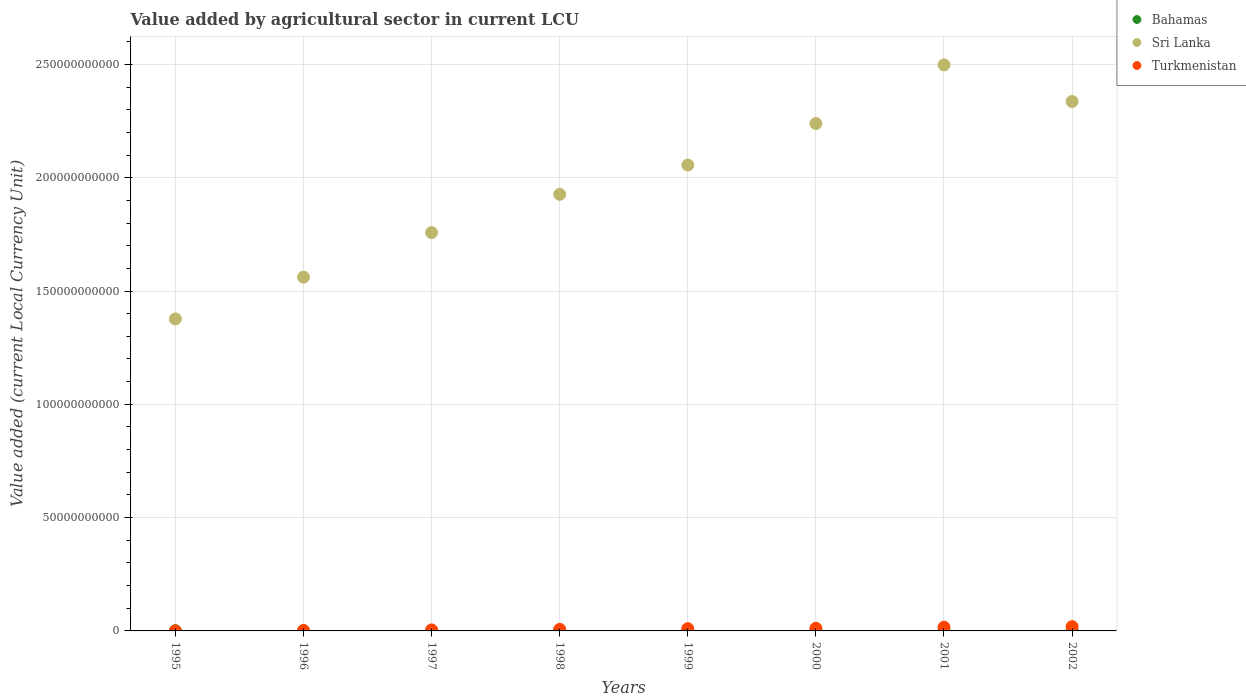What is the value added by agricultural sector in Turkmenistan in 2002?
Provide a short and direct response. 1.89e+09. Across all years, what is the maximum value added by agricultural sector in Bahamas?
Your response must be concise. 2.02e+08. Across all years, what is the minimum value added by agricultural sector in Bahamas?
Make the answer very short. 9.55e+07. In which year was the value added by agricultural sector in Sri Lanka minimum?
Provide a short and direct response. 1995. What is the total value added by agricultural sector in Turkmenistan in the graph?
Your response must be concise. 7.10e+09. What is the difference between the value added by agricultural sector in Sri Lanka in 1995 and that in 1998?
Your answer should be very brief. -5.50e+1. What is the difference between the value added by agricultural sector in Turkmenistan in 2002 and the value added by agricultural sector in Sri Lanka in 1995?
Offer a very short reply. -1.36e+11. What is the average value added by agricultural sector in Turkmenistan per year?
Provide a short and direct response. 8.88e+08. In the year 1995, what is the difference between the value added by agricultural sector in Bahamas and value added by agricultural sector in Turkmenistan?
Provide a short and direct response. 7.60e+07. What is the ratio of the value added by agricultural sector in Turkmenistan in 1997 to that in 1998?
Make the answer very short. 0.64. Is the value added by agricultural sector in Bahamas in 1995 less than that in 2002?
Provide a short and direct response. Yes. What is the difference between the highest and the second highest value added by agricultural sector in Sri Lanka?
Make the answer very short. 1.62e+1. What is the difference between the highest and the lowest value added by agricultural sector in Turkmenistan?
Offer a terse response. 1.87e+09. In how many years, is the value added by agricultural sector in Sri Lanka greater than the average value added by agricultural sector in Sri Lanka taken over all years?
Offer a very short reply. 4. Is the sum of the value added by agricultural sector in Turkmenistan in 1998 and 2002 greater than the maximum value added by agricultural sector in Sri Lanka across all years?
Ensure brevity in your answer.  No. Is it the case that in every year, the sum of the value added by agricultural sector in Bahamas and value added by agricultural sector in Turkmenistan  is greater than the value added by agricultural sector in Sri Lanka?
Make the answer very short. No. Is the value added by agricultural sector in Sri Lanka strictly greater than the value added by agricultural sector in Turkmenistan over the years?
Offer a very short reply. Yes. How many dotlines are there?
Your answer should be compact. 3. How many years are there in the graph?
Provide a short and direct response. 8. What is the difference between two consecutive major ticks on the Y-axis?
Provide a short and direct response. 5.00e+1. Are the values on the major ticks of Y-axis written in scientific E-notation?
Keep it short and to the point. No. Where does the legend appear in the graph?
Give a very brief answer. Top right. What is the title of the graph?
Your response must be concise. Value added by agricultural sector in current LCU. Does "Kuwait" appear as one of the legend labels in the graph?
Your answer should be very brief. No. What is the label or title of the X-axis?
Your response must be concise. Years. What is the label or title of the Y-axis?
Offer a very short reply. Value added (current Local Currency Unit). What is the Value added (current Local Currency Unit) in Bahamas in 1995?
Your response must be concise. 9.72e+07. What is the Value added (current Local Currency Unit) of Sri Lanka in 1995?
Provide a succinct answer. 1.38e+11. What is the Value added (current Local Currency Unit) in Turkmenistan in 1995?
Provide a succinct answer. 2.11e+07. What is the Value added (current Local Currency Unit) in Bahamas in 1996?
Your response must be concise. 9.55e+07. What is the Value added (current Local Currency Unit) of Sri Lanka in 1996?
Keep it short and to the point. 1.56e+11. What is the Value added (current Local Currency Unit) of Turkmenistan in 1996?
Keep it short and to the point. 1.96e+08. What is the Value added (current Local Currency Unit) in Bahamas in 1997?
Offer a very short reply. 1.54e+08. What is the Value added (current Local Currency Unit) in Sri Lanka in 1997?
Ensure brevity in your answer.  1.76e+11. What is the Value added (current Local Currency Unit) in Turkmenistan in 1997?
Your response must be concise. 4.50e+08. What is the Value added (current Local Currency Unit) of Bahamas in 1998?
Keep it short and to the point. 1.47e+08. What is the Value added (current Local Currency Unit) of Sri Lanka in 1998?
Your response must be concise. 1.93e+11. What is the Value added (current Local Currency Unit) in Turkmenistan in 1998?
Offer a very short reply. 7.04e+08. What is the Value added (current Local Currency Unit) in Bahamas in 1999?
Your response must be concise. 1.48e+08. What is the Value added (current Local Currency Unit) in Sri Lanka in 1999?
Ensure brevity in your answer.  2.06e+11. What is the Value added (current Local Currency Unit) of Turkmenistan in 1999?
Provide a succinct answer. 9.96e+08. What is the Value added (current Local Currency Unit) of Bahamas in 2000?
Your response must be concise. 1.66e+08. What is the Value added (current Local Currency Unit) of Sri Lanka in 2000?
Provide a short and direct response. 2.24e+11. What is the Value added (current Local Currency Unit) of Turkmenistan in 2000?
Offer a very short reply. 1.18e+09. What is the Value added (current Local Currency Unit) of Bahamas in 2001?
Ensure brevity in your answer.  1.57e+08. What is the Value added (current Local Currency Unit) in Sri Lanka in 2001?
Ensure brevity in your answer.  2.50e+11. What is the Value added (current Local Currency Unit) of Turkmenistan in 2001?
Provide a short and direct response. 1.67e+09. What is the Value added (current Local Currency Unit) in Bahamas in 2002?
Your answer should be compact. 2.02e+08. What is the Value added (current Local Currency Unit) of Sri Lanka in 2002?
Your answer should be compact. 2.34e+11. What is the Value added (current Local Currency Unit) in Turkmenistan in 2002?
Your response must be concise. 1.89e+09. Across all years, what is the maximum Value added (current Local Currency Unit) in Bahamas?
Offer a terse response. 2.02e+08. Across all years, what is the maximum Value added (current Local Currency Unit) of Sri Lanka?
Your answer should be very brief. 2.50e+11. Across all years, what is the maximum Value added (current Local Currency Unit) of Turkmenistan?
Provide a short and direct response. 1.89e+09. Across all years, what is the minimum Value added (current Local Currency Unit) of Bahamas?
Your answer should be compact. 9.55e+07. Across all years, what is the minimum Value added (current Local Currency Unit) in Sri Lanka?
Keep it short and to the point. 1.38e+11. Across all years, what is the minimum Value added (current Local Currency Unit) of Turkmenistan?
Your answer should be compact. 2.11e+07. What is the total Value added (current Local Currency Unit) in Bahamas in the graph?
Provide a short and direct response. 1.17e+09. What is the total Value added (current Local Currency Unit) in Sri Lanka in the graph?
Your response must be concise. 1.58e+12. What is the total Value added (current Local Currency Unit) in Turkmenistan in the graph?
Your answer should be compact. 7.10e+09. What is the difference between the Value added (current Local Currency Unit) of Bahamas in 1995 and that in 1996?
Offer a very short reply. 1.66e+06. What is the difference between the Value added (current Local Currency Unit) of Sri Lanka in 1995 and that in 1996?
Ensure brevity in your answer.  -1.84e+1. What is the difference between the Value added (current Local Currency Unit) in Turkmenistan in 1995 and that in 1996?
Your response must be concise. -1.75e+08. What is the difference between the Value added (current Local Currency Unit) of Bahamas in 1995 and that in 1997?
Give a very brief answer. -5.66e+07. What is the difference between the Value added (current Local Currency Unit) in Sri Lanka in 1995 and that in 1997?
Offer a very short reply. -3.81e+1. What is the difference between the Value added (current Local Currency Unit) of Turkmenistan in 1995 and that in 1997?
Offer a terse response. -4.28e+08. What is the difference between the Value added (current Local Currency Unit) in Bahamas in 1995 and that in 1998?
Offer a very short reply. -4.99e+07. What is the difference between the Value added (current Local Currency Unit) of Sri Lanka in 1995 and that in 1998?
Give a very brief answer. -5.50e+1. What is the difference between the Value added (current Local Currency Unit) of Turkmenistan in 1995 and that in 1998?
Your answer should be compact. -6.83e+08. What is the difference between the Value added (current Local Currency Unit) of Bahamas in 1995 and that in 1999?
Ensure brevity in your answer.  -5.08e+07. What is the difference between the Value added (current Local Currency Unit) in Sri Lanka in 1995 and that in 1999?
Keep it short and to the point. -6.79e+1. What is the difference between the Value added (current Local Currency Unit) in Turkmenistan in 1995 and that in 1999?
Offer a very short reply. -9.75e+08. What is the difference between the Value added (current Local Currency Unit) of Bahamas in 1995 and that in 2000?
Keep it short and to the point. -6.85e+07. What is the difference between the Value added (current Local Currency Unit) of Sri Lanka in 1995 and that in 2000?
Offer a terse response. -8.62e+1. What is the difference between the Value added (current Local Currency Unit) in Turkmenistan in 1995 and that in 2000?
Ensure brevity in your answer.  -1.16e+09. What is the difference between the Value added (current Local Currency Unit) in Bahamas in 1995 and that in 2001?
Provide a succinct answer. -5.99e+07. What is the difference between the Value added (current Local Currency Unit) of Sri Lanka in 1995 and that in 2001?
Give a very brief answer. -1.12e+11. What is the difference between the Value added (current Local Currency Unit) of Turkmenistan in 1995 and that in 2001?
Provide a succinct answer. -1.64e+09. What is the difference between the Value added (current Local Currency Unit) of Bahamas in 1995 and that in 2002?
Make the answer very short. -1.05e+08. What is the difference between the Value added (current Local Currency Unit) in Sri Lanka in 1995 and that in 2002?
Your answer should be very brief. -9.59e+1. What is the difference between the Value added (current Local Currency Unit) in Turkmenistan in 1995 and that in 2002?
Your response must be concise. -1.87e+09. What is the difference between the Value added (current Local Currency Unit) in Bahamas in 1996 and that in 1997?
Provide a short and direct response. -5.82e+07. What is the difference between the Value added (current Local Currency Unit) in Sri Lanka in 1996 and that in 1997?
Provide a succinct answer. -1.97e+1. What is the difference between the Value added (current Local Currency Unit) of Turkmenistan in 1996 and that in 1997?
Provide a short and direct response. -2.54e+08. What is the difference between the Value added (current Local Currency Unit) in Bahamas in 1996 and that in 1998?
Keep it short and to the point. -5.16e+07. What is the difference between the Value added (current Local Currency Unit) in Sri Lanka in 1996 and that in 1998?
Offer a terse response. -3.66e+1. What is the difference between the Value added (current Local Currency Unit) of Turkmenistan in 1996 and that in 1998?
Offer a terse response. -5.08e+08. What is the difference between the Value added (current Local Currency Unit) of Bahamas in 1996 and that in 1999?
Your answer should be compact. -5.24e+07. What is the difference between the Value added (current Local Currency Unit) of Sri Lanka in 1996 and that in 1999?
Your answer should be very brief. -4.95e+1. What is the difference between the Value added (current Local Currency Unit) of Turkmenistan in 1996 and that in 1999?
Ensure brevity in your answer.  -8.01e+08. What is the difference between the Value added (current Local Currency Unit) in Bahamas in 1996 and that in 2000?
Give a very brief answer. -7.01e+07. What is the difference between the Value added (current Local Currency Unit) of Sri Lanka in 1996 and that in 2000?
Provide a succinct answer. -6.78e+1. What is the difference between the Value added (current Local Currency Unit) of Turkmenistan in 1996 and that in 2000?
Ensure brevity in your answer.  -9.81e+08. What is the difference between the Value added (current Local Currency Unit) in Bahamas in 1996 and that in 2001?
Your answer should be very brief. -6.16e+07. What is the difference between the Value added (current Local Currency Unit) of Sri Lanka in 1996 and that in 2001?
Give a very brief answer. -9.37e+1. What is the difference between the Value added (current Local Currency Unit) of Turkmenistan in 1996 and that in 2001?
Make the answer very short. -1.47e+09. What is the difference between the Value added (current Local Currency Unit) of Bahamas in 1996 and that in 2002?
Make the answer very short. -1.06e+08. What is the difference between the Value added (current Local Currency Unit) in Sri Lanka in 1996 and that in 2002?
Your answer should be compact. -7.75e+1. What is the difference between the Value added (current Local Currency Unit) of Turkmenistan in 1996 and that in 2002?
Your answer should be compact. -1.70e+09. What is the difference between the Value added (current Local Currency Unit) of Bahamas in 1997 and that in 1998?
Your answer should be compact. 6.64e+06. What is the difference between the Value added (current Local Currency Unit) in Sri Lanka in 1997 and that in 1998?
Provide a succinct answer. -1.69e+1. What is the difference between the Value added (current Local Currency Unit) in Turkmenistan in 1997 and that in 1998?
Offer a terse response. -2.55e+08. What is the difference between the Value added (current Local Currency Unit) in Bahamas in 1997 and that in 1999?
Your response must be concise. 5.82e+06. What is the difference between the Value added (current Local Currency Unit) in Sri Lanka in 1997 and that in 1999?
Give a very brief answer. -2.98e+1. What is the difference between the Value added (current Local Currency Unit) in Turkmenistan in 1997 and that in 1999?
Offer a very short reply. -5.47e+08. What is the difference between the Value added (current Local Currency Unit) in Bahamas in 1997 and that in 2000?
Offer a very short reply. -1.19e+07. What is the difference between the Value added (current Local Currency Unit) in Sri Lanka in 1997 and that in 2000?
Give a very brief answer. -4.82e+1. What is the difference between the Value added (current Local Currency Unit) of Turkmenistan in 1997 and that in 2000?
Provide a short and direct response. -7.28e+08. What is the difference between the Value added (current Local Currency Unit) in Bahamas in 1997 and that in 2001?
Provide a succinct answer. -3.32e+06. What is the difference between the Value added (current Local Currency Unit) of Sri Lanka in 1997 and that in 2001?
Your response must be concise. -7.40e+1. What is the difference between the Value added (current Local Currency Unit) of Turkmenistan in 1997 and that in 2001?
Your response must be concise. -1.22e+09. What is the difference between the Value added (current Local Currency Unit) in Bahamas in 1997 and that in 2002?
Give a very brief answer. -4.81e+07. What is the difference between the Value added (current Local Currency Unit) in Sri Lanka in 1997 and that in 2002?
Offer a terse response. -5.78e+1. What is the difference between the Value added (current Local Currency Unit) in Turkmenistan in 1997 and that in 2002?
Give a very brief answer. -1.44e+09. What is the difference between the Value added (current Local Currency Unit) of Bahamas in 1998 and that in 1999?
Give a very brief answer. -8.26e+05. What is the difference between the Value added (current Local Currency Unit) in Sri Lanka in 1998 and that in 1999?
Provide a succinct answer. -1.29e+1. What is the difference between the Value added (current Local Currency Unit) in Turkmenistan in 1998 and that in 1999?
Ensure brevity in your answer.  -2.92e+08. What is the difference between the Value added (current Local Currency Unit) of Bahamas in 1998 and that in 2000?
Make the answer very short. -1.85e+07. What is the difference between the Value added (current Local Currency Unit) of Sri Lanka in 1998 and that in 2000?
Your answer should be compact. -3.13e+1. What is the difference between the Value added (current Local Currency Unit) in Turkmenistan in 1998 and that in 2000?
Offer a terse response. -4.73e+08. What is the difference between the Value added (current Local Currency Unit) of Bahamas in 1998 and that in 2001?
Give a very brief answer. -9.96e+06. What is the difference between the Value added (current Local Currency Unit) of Sri Lanka in 1998 and that in 2001?
Keep it short and to the point. -5.71e+1. What is the difference between the Value added (current Local Currency Unit) in Turkmenistan in 1998 and that in 2001?
Offer a terse response. -9.61e+08. What is the difference between the Value added (current Local Currency Unit) of Bahamas in 1998 and that in 2002?
Offer a very short reply. -5.47e+07. What is the difference between the Value added (current Local Currency Unit) of Sri Lanka in 1998 and that in 2002?
Provide a succinct answer. -4.10e+1. What is the difference between the Value added (current Local Currency Unit) of Turkmenistan in 1998 and that in 2002?
Provide a short and direct response. -1.19e+09. What is the difference between the Value added (current Local Currency Unit) of Bahamas in 1999 and that in 2000?
Provide a succinct answer. -1.77e+07. What is the difference between the Value added (current Local Currency Unit) of Sri Lanka in 1999 and that in 2000?
Make the answer very short. -1.83e+1. What is the difference between the Value added (current Local Currency Unit) in Turkmenistan in 1999 and that in 2000?
Provide a short and direct response. -1.81e+08. What is the difference between the Value added (current Local Currency Unit) of Bahamas in 1999 and that in 2001?
Give a very brief answer. -9.13e+06. What is the difference between the Value added (current Local Currency Unit) in Sri Lanka in 1999 and that in 2001?
Provide a succinct answer. -4.42e+1. What is the difference between the Value added (current Local Currency Unit) in Turkmenistan in 1999 and that in 2001?
Keep it short and to the point. -6.69e+08. What is the difference between the Value added (current Local Currency Unit) in Bahamas in 1999 and that in 2002?
Give a very brief answer. -5.39e+07. What is the difference between the Value added (current Local Currency Unit) of Sri Lanka in 1999 and that in 2002?
Keep it short and to the point. -2.80e+1. What is the difference between the Value added (current Local Currency Unit) in Turkmenistan in 1999 and that in 2002?
Ensure brevity in your answer.  -8.98e+08. What is the difference between the Value added (current Local Currency Unit) in Bahamas in 2000 and that in 2001?
Offer a very short reply. 8.59e+06. What is the difference between the Value added (current Local Currency Unit) of Sri Lanka in 2000 and that in 2001?
Offer a very short reply. -2.59e+1. What is the difference between the Value added (current Local Currency Unit) in Turkmenistan in 2000 and that in 2001?
Offer a very short reply. -4.88e+08. What is the difference between the Value added (current Local Currency Unit) in Bahamas in 2000 and that in 2002?
Make the answer very short. -3.62e+07. What is the difference between the Value added (current Local Currency Unit) in Sri Lanka in 2000 and that in 2002?
Make the answer very short. -9.69e+09. What is the difference between the Value added (current Local Currency Unit) of Turkmenistan in 2000 and that in 2002?
Keep it short and to the point. -7.17e+08. What is the difference between the Value added (current Local Currency Unit) of Bahamas in 2001 and that in 2002?
Your answer should be very brief. -4.48e+07. What is the difference between the Value added (current Local Currency Unit) in Sri Lanka in 2001 and that in 2002?
Your answer should be compact. 1.62e+1. What is the difference between the Value added (current Local Currency Unit) in Turkmenistan in 2001 and that in 2002?
Offer a terse response. -2.28e+08. What is the difference between the Value added (current Local Currency Unit) of Bahamas in 1995 and the Value added (current Local Currency Unit) of Sri Lanka in 1996?
Ensure brevity in your answer.  -1.56e+11. What is the difference between the Value added (current Local Currency Unit) in Bahamas in 1995 and the Value added (current Local Currency Unit) in Turkmenistan in 1996?
Give a very brief answer. -9.86e+07. What is the difference between the Value added (current Local Currency Unit) of Sri Lanka in 1995 and the Value added (current Local Currency Unit) of Turkmenistan in 1996?
Make the answer very short. 1.37e+11. What is the difference between the Value added (current Local Currency Unit) in Bahamas in 1995 and the Value added (current Local Currency Unit) in Sri Lanka in 1997?
Offer a terse response. -1.76e+11. What is the difference between the Value added (current Local Currency Unit) of Bahamas in 1995 and the Value added (current Local Currency Unit) of Turkmenistan in 1997?
Ensure brevity in your answer.  -3.52e+08. What is the difference between the Value added (current Local Currency Unit) in Sri Lanka in 1995 and the Value added (current Local Currency Unit) in Turkmenistan in 1997?
Offer a terse response. 1.37e+11. What is the difference between the Value added (current Local Currency Unit) of Bahamas in 1995 and the Value added (current Local Currency Unit) of Sri Lanka in 1998?
Your answer should be compact. -1.93e+11. What is the difference between the Value added (current Local Currency Unit) in Bahamas in 1995 and the Value added (current Local Currency Unit) in Turkmenistan in 1998?
Ensure brevity in your answer.  -6.07e+08. What is the difference between the Value added (current Local Currency Unit) in Sri Lanka in 1995 and the Value added (current Local Currency Unit) in Turkmenistan in 1998?
Provide a short and direct response. 1.37e+11. What is the difference between the Value added (current Local Currency Unit) of Bahamas in 1995 and the Value added (current Local Currency Unit) of Sri Lanka in 1999?
Make the answer very short. -2.06e+11. What is the difference between the Value added (current Local Currency Unit) in Bahamas in 1995 and the Value added (current Local Currency Unit) in Turkmenistan in 1999?
Make the answer very short. -8.99e+08. What is the difference between the Value added (current Local Currency Unit) in Sri Lanka in 1995 and the Value added (current Local Currency Unit) in Turkmenistan in 1999?
Give a very brief answer. 1.37e+11. What is the difference between the Value added (current Local Currency Unit) in Bahamas in 1995 and the Value added (current Local Currency Unit) in Sri Lanka in 2000?
Keep it short and to the point. -2.24e+11. What is the difference between the Value added (current Local Currency Unit) of Bahamas in 1995 and the Value added (current Local Currency Unit) of Turkmenistan in 2000?
Offer a terse response. -1.08e+09. What is the difference between the Value added (current Local Currency Unit) of Sri Lanka in 1995 and the Value added (current Local Currency Unit) of Turkmenistan in 2000?
Provide a succinct answer. 1.37e+11. What is the difference between the Value added (current Local Currency Unit) in Bahamas in 1995 and the Value added (current Local Currency Unit) in Sri Lanka in 2001?
Ensure brevity in your answer.  -2.50e+11. What is the difference between the Value added (current Local Currency Unit) of Bahamas in 1995 and the Value added (current Local Currency Unit) of Turkmenistan in 2001?
Your answer should be compact. -1.57e+09. What is the difference between the Value added (current Local Currency Unit) of Sri Lanka in 1995 and the Value added (current Local Currency Unit) of Turkmenistan in 2001?
Give a very brief answer. 1.36e+11. What is the difference between the Value added (current Local Currency Unit) of Bahamas in 1995 and the Value added (current Local Currency Unit) of Sri Lanka in 2002?
Keep it short and to the point. -2.34e+11. What is the difference between the Value added (current Local Currency Unit) in Bahamas in 1995 and the Value added (current Local Currency Unit) in Turkmenistan in 2002?
Provide a succinct answer. -1.80e+09. What is the difference between the Value added (current Local Currency Unit) of Sri Lanka in 1995 and the Value added (current Local Currency Unit) of Turkmenistan in 2002?
Your response must be concise. 1.36e+11. What is the difference between the Value added (current Local Currency Unit) of Bahamas in 1996 and the Value added (current Local Currency Unit) of Sri Lanka in 1997?
Give a very brief answer. -1.76e+11. What is the difference between the Value added (current Local Currency Unit) in Bahamas in 1996 and the Value added (current Local Currency Unit) in Turkmenistan in 1997?
Offer a very short reply. -3.54e+08. What is the difference between the Value added (current Local Currency Unit) of Sri Lanka in 1996 and the Value added (current Local Currency Unit) of Turkmenistan in 1997?
Your answer should be compact. 1.56e+11. What is the difference between the Value added (current Local Currency Unit) of Bahamas in 1996 and the Value added (current Local Currency Unit) of Sri Lanka in 1998?
Your answer should be very brief. -1.93e+11. What is the difference between the Value added (current Local Currency Unit) of Bahamas in 1996 and the Value added (current Local Currency Unit) of Turkmenistan in 1998?
Make the answer very short. -6.09e+08. What is the difference between the Value added (current Local Currency Unit) of Sri Lanka in 1996 and the Value added (current Local Currency Unit) of Turkmenistan in 1998?
Your response must be concise. 1.55e+11. What is the difference between the Value added (current Local Currency Unit) in Bahamas in 1996 and the Value added (current Local Currency Unit) in Sri Lanka in 1999?
Make the answer very short. -2.06e+11. What is the difference between the Value added (current Local Currency Unit) in Bahamas in 1996 and the Value added (current Local Currency Unit) in Turkmenistan in 1999?
Provide a succinct answer. -9.01e+08. What is the difference between the Value added (current Local Currency Unit) in Sri Lanka in 1996 and the Value added (current Local Currency Unit) in Turkmenistan in 1999?
Your answer should be compact. 1.55e+11. What is the difference between the Value added (current Local Currency Unit) of Bahamas in 1996 and the Value added (current Local Currency Unit) of Sri Lanka in 2000?
Offer a terse response. -2.24e+11. What is the difference between the Value added (current Local Currency Unit) of Bahamas in 1996 and the Value added (current Local Currency Unit) of Turkmenistan in 2000?
Offer a very short reply. -1.08e+09. What is the difference between the Value added (current Local Currency Unit) in Sri Lanka in 1996 and the Value added (current Local Currency Unit) in Turkmenistan in 2000?
Provide a short and direct response. 1.55e+11. What is the difference between the Value added (current Local Currency Unit) of Bahamas in 1996 and the Value added (current Local Currency Unit) of Sri Lanka in 2001?
Make the answer very short. -2.50e+11. What is the difference between the Value added (current Local Currency Unit) in Bahamas in 1996 and the Value added (current Local Currency Unit) in Turkmenistan in 2001?
Provide a short and direct response. -1.57e+09. What is the difference between the Value added (current Local Currency Unit) of Sri Lanka in 1996 and the Value added (current Local Currency Unit) of Turkmenistan in 2001?
Provide a succinct answer. 1.54e+11. What is the difference between the Value added (current Local Currency Unit) in Bahamas in 1996 and the Value added (current Local Currency Unit) in Sri Lanka in 2002?
Your response must be concise. -2.34e+11. What is the difference between the Value added (current Local Currency Unit) of Bahamas in 1996 and the Value added (current Local Currency Unit) of Turkmenistan in 2002?
Keep it short and to the point. -1.80e+09. What is the difference between the Value added (current Local Currency Unit) in Sri Lanka in 1996 and the Value added (current Local Currency Unit) in Turkmenistan in 2002?
Your answer should be very brief. 1.54e+11. What is the difference between the Value added (current Local Currency Unit) of Bahamas in 1997 and the Value added (current Local Currency Unit) of Sri Lanka in 1998?
Keep it short and to the point. -1.93e+11. What is the difference between the Value added (current Local Currency Unit) of Bahamas in 1997 and the Value added (current Local Currency Unit) of Turkmenistan in 1998?
Give a very brief answer. -5.50e+08. What is the difference between the Value added (current Local Currency Unit) of Sri Lanka in 1997 and the Value added (current Local Currency Unit) of Turkmenistan in 1998?
Offer a very short reply. 1.75e+11. What is the difference between the Value added (current Local Currency Unit) in Bahamas in 1997 and the Value added (current Local Currency Unit) in Sri Lanka in 1999?
Offer a terse response. -2.05e+11. What is the difference between the Value added (current Local Currency Unit) of Bahamas in 1997 and the Value added (current Local Currency Unit) of Turkmenistan in 1999?
Offer a very short reply. -8.43e+08. What is the difference between the Value added (current Local Currency Unit) in Sri Lanka in 1997 and the Value added (current Local Currency Unit) in Turkmenistan in 1999?
Provide a succinct answer. 1.75e+11. What is the difference between the Value added (current Local Currency Unit) of Bahamas in 1997 and the Value added (current Local Currency Unit) of Sri Lanka in 2000?
Make the answer very short. -2.24e+11. What is the difference between the Value added (current Local Currency Unit) of Bahamas in 1997 and the Value added (current Local Currency Unit) of Turkmenistan in 2000?
Your answer should be very brief. -1.02e+09. What is the difference between the Value added (current Local Currency Unit) in Sri Lanka in 1997 and the Value added (current Local Currency Unit) in Turkmenistan in 2000?
Make the answer very short. 1.75e+11. What is the difference between the Value added (current Local Currency Unit) of Bahamas in 1997 and the Value added (current Local Currency Unit) of Sri Lanka in 2001?
Make the answer very short. -2.50e+11. What is the difference between the Value added (current Local Currency Unit) of Bahamas in 1997 and the Value added (current Local Currency Unit) of Turkmenistan in 2001?
Provide a succinct answer. -1.51e+09. What is the difference between the Value added (current Local Currency Unit) in Sri Lanka in 1997 and the Value added (current Local Currency Unit) in Turkmenistan in 2001?
Provide a short and direct response. 1.74e+11. What is the difference between the Value added (current Local Currency Unit) of Bahamas in 1997 and the Value added (current Local Currency Unit) of Sri Lanka in 2002?
Offer a terse response. -2.33e+11. What is the difference between the Value added (current Local Currency Unit) in Bahamas in 1997 and the Value added (current Local Currency Unit) in Turkmenistan in 2002?
Your response must be concise. -1.74e+09. What is the difference between the Value added (current Local Currency Unit) of Sri Lanka in 1997 and the Value added (current Local Currency Unit) of Turkmenistan in 2002?
Give a very brief answer. 1.74e+11. What is the difference between the Value added (current Local Currency Unit) of Bahamas in 1998 and the Value added (current Local Currency Unit) of Sri Lanka in 1999?
Make the answer very short. -2.05e+11. What is the difference between the Value added (current Local Currency Unit) in Bahamas in 1998 and the Value added (current Local Currency Unit) in Turkmenistan in 1999?
Provide a short and direct response. -8.49e+08. What is the difference between the Value added (current Local Currency Unit) in Sri Lanka in 1998 and the Value added (current Local Currency Unit) in Turkmenistan in 1999?
Your answer should be compact. 1.92e+11. What is the difference between the Value added (current Local Currency Unit) in Bahamas in 1998 and the Value added (current Local Currency Unit) in Sri Lanka in 2000?
Provide a short and direct response. -2.24e+11. What is the difference between the Value added (current Local Currency Unit) of Bahamas in 1998 and the Value added (current Local Currency Unit) of Turkmenistan in 2000?
Your answer should be compact. -1.03e+09. What is the difference between the Value added (current Local Currency Unit) of Sri Lanka in 1998 and the Value added (current Local Currency Unit) of Turkmenistan in 2000?
Give a very brief answer. 1.91e+11. What is the difference between the Value added (current Local Currency Unit) in Bahamas in 1998 and the Value added (current Local Currency Unit) in Sri Lanka in 2001?
Provide a short and direct response. -2.50e+11. What is the difference between the Value added (current Local Currency Unit) of Bahamas in 1998 and the Value added (current Local Currency Unit) of Turkmenistan in 2001?
Ensure brevity in your answer.  -1.52e+09. What is the difference between the Value added (current Local Currency Unit) of Sri Lanka in 1998 and the Value added (current Local Currency Unit) of Turkmenistan in 2001?
Your answer should be very brief. 1.91e+11. What is the difference between the Value added (current Local Currency Unit) in Bahamas in 1998 and the Value added (current Local Currency Unit) in Sri Lanka in 2002?
Your response must be concise. -2.33e+11. What is the difference between the Value added (current Local Currency Unit) of Bahamas in 1998 and the Value added (current Local Currency Unit) of Turkmenistan in 2002?
Ensure brevity in your answer.  -1.75e+09. What is the difference between the Value added (current Local Currency Unit) of Sri Lanka in 1998 and the Value added (current Local Currency Unit) of Turkmenistan in 2002?
Provide a succinct answer. 1.91e+11. What is the difference between the Value added (current Local Currency Unit) in Bahamas in 1999 and the Value added (current Local Currency Unit) in Sri Lanka in 2000?
Your response must be concise. -2.24e+11. What is the difference between the Value added (current Local Currency Unit) of Bahamas in 1999 and the Value added (current Local Currency Unit) of Turkmenistan in 2000?
Your answer should be very brief. -1.03e+09. What is the difference between the Value added (current Local Currency Unit) in Sri Lanka in 1999 and the Value added (current Local Currency Unit) in Turkmenistan in 2000?
Your answer should be compact. 2.04e+11. What is the difference between the Value added (current Local Currency Unit) of Bahamas in 1999 and the Value added (current Local Currency Unit) of Sri Lanka in 2001?
Your response must be concise. -2.50e+11. What is the difference between the Value added (current Local Currency Unit) of Bahamas in 1999 and the Value added (current Local Currency Unit) of Turkmenistan in 2001?
Keep it short and to the point. -1.52e+09. What is the difference between the Value added (current Local Currency Unit) in Sri Lanka in 1999 and the Value added (current Local Currency Unit) in Turkmenistan in 2001?
Keep it short and to the point. 2.04e+11. What is the difference between the Value added (current Local Currency Unit) in Bahamas in 1999 and the Value added (current Local Currency Unit) in Sri Lanka in 2002?
Your answer should be compact. -2.33e+11. What is the difference between the Value added (current Local Currency Unit) in Bahamas in 1999 and the Value added (current Local Currency Unit) in Turkmenistan in 2002?
Provide a short and direct response. -1.75e+09. What is the difference between the Value added (current Local Currency Unit) in Sri Lanka in 1999 and the Value added (current Local Currency Unit) in Turkmenistan in 2002?
Your response must be concise. 2.04e+11. What is the difference between the Value added (current Local Currency Unit) of Bahamas in 2000 and the Value added (current Local Currency Unit) of Sri Lanka in 2001?
Ensure brevity in your answer.  -2.50e+11. What is the difference between the Value added (current Local Currency Unit) of Bahamas in 2000 and the Value added (current Local Currency Unit) of Turkmenistan in 2001?
Provide a succinct answer. -1.50e+09. What is the difference between the Value added (current Local Currency Unit) in Sri Lanka in 2000 and the Value added (current Local Currency Unit) in Turkmenistan in 2001?
Ensure brevity in your answer.  2.22e+11. What is the difference between the Value added (current Local Currency Unit) of Bahamas in 2000 and the Value added (current Local Currency Unit) of Sri Lanka in 2002?
Keep it short and to the point. -2.33e+11. What is the difference between the Value added (current Local Currency Unit) in Bahamas in 2000 and the Value added (current Local Currency Unit) in Turkmenistan in 2002?
Keep it short and to the point. -1.73e+09. What is the difference between the Value added (current Local Currency Unit) in Sri Lanka in 2000 and the Value added (current Local Currency Unit) in Turkmenistan in 2002?
Provide a short and direct response. 2.22e+11. What is the difference between the Value added (current Local Currency Unit) of Bahamas in 2001 and the Value added (current Local Currency Unit) of Sri Lanka in 2002?
Give a very brief answer. -2.33e+11. What is the difference between the Value added (current Local Currency Unit) of Bahamas in 2001 and the Value added (current Local Currency Unit) of Turkmenistan in 2002?
Offer a terse response. -1.74e+09. What is the difference between the Value added (current Local Currency Unit) of Sri Lanka in 2001 and the Value added (current Local Currency Unit) of Turkmenistan in 2002?
Provide a succinct answer. 2.48e+11. What is the average Value added (current Local Currency Unit) of Bahamas per year?
Ensure brevity in your answer.  1.46e+08. What is the average Value added (current Local Currency Unit) in Sri Lanka per year?
Provide a succinct answer. 1.97e+11. What is the average Value added (current Local Currency Unit) in Turkmenistan per year?
Your response must be concise. 8.88e+08. In the year 1995, what is the difference between the Value added (current Local Currency Unit) in Bahamas and Value added (current Local Currency Unit) in Sri Lanka?
Give a very brief answer. -1.38e+11. In the year 1995, what is the difference between the Value added (current Local Currency Unit) in Bahamas and Value added (current Local Currency Unit) in Turkmenistan?
Make the answer very short. 7.60e+07. In the year 1995, what is the difference between the Value added (current Local Currency Unit) of Sri Lanka and Value added (current Local Currency Unit) of Turkmenistan?
Your answer should be compact. 1.38e+11. In the year 1996, what is the difference between the Value added (current Local Currency Unit) of Bahamas and Value added (current Local Currency Unit) of Sri Lanka?
Provide a short and direct response. -1.56e+11. In the year 1996, what is the difference between the Value added (current Local Currency Unit) in Bahamas and Value added (current Local Currency Unit) in Turkmenistan?
Offer a very short reply. -1.00e+08. In the year 1996, what is the difference between the Value added (current Local Currency Unit) in Sri Lanka and Value added (current Local Currency Unit) in Turkmenistan?
Provide a succinct answer. 1.56e+11. In the year 1997, what is the difference between the Value added (current Local Currency Unit) in Bahamas and Value added (current Local Currency Unit) in Sri Lanka?
Make the answer very short. -1.76e+11. In the year 1997, what is the difference between the Value added (current Local Currency Unit) in Bahamas and Value added (current Local Currency Unit) in Turkmenistan?
Give a very brief answer. -2.96e+08. In the year 1997, what is the difference between the Value added (current Local Currency Unit) in Sri Lanka and Value added (current Local Currency Unit) in Turkmenistan?
Offer a very short reply. 1.75e+11. In the year 1998, what is the difference between the Value added (current Local Currency Unit) of Bahamas and Value added (current Local Currency Unit) of Sri Lanka?
Your answer should be compact. -1.93e+11. In the year 1998, what is the difference between the Value added (current Local Currency Unit) of Bahamas and Value added (current Local Currency Unit) of Turkmenistan?
Your response must be concise. -5.57e+08. In the year 1998, what is the difference between the Value added (current Local Currency Unit) of Sri Lanka and Value added (current Local Currency Unit) of Turkmenistan?
Provide a succinct answer. 1.92e+11. In the year 1999, what is the difference between the Value added (current Local Currency Unit) in Bahamas and Value added (current Local Currency Unit) in Sri Lanka?
Give a very brief answer. -2.05e+11. In the year 1999, what is the difference between the Value added (current Local Currency Unit) in Bahamas and Value added (current Local Currency Unit) in Turkmenistan?
Provide a short and direct response. -8.48e+08. In the year 1999, what is the difference between the Value added (current Local Currency Unit) in Sri Lanka and Value added (current Local Currency Unit) in Turkmenistan?
Your response must be concise. 2.05e+11. In the year 2000, what is the difference between the Value added (current Local Currency Unit) in Bahamas and Value added (current Local Currency Unit) in Sri Lanka?
Your answer should be very brief. -2.24e+11. In the year 2000, what is the difference between the Value added (current Local Currency Unit) of Bahamas and Value added (current Local Currency Unit) of Turkmenistan?
Give a very brief answer. -1.01e+09. In the year 2000, what is the difference between the Value added (current Local Currency Unit) in Sri Lanka and Value added (current Local Currency Unit) in Turkmenistan?
Provide a succinct answer. 2.23e+11. In the year 2001, what is the difference between the Value added (current Local Currency Unit) in Bahamas and Value added (current Local Currency Unit) in Sri Lanka?
Your answer should be compact. -2.50e+11. In the year 2001, what is the difference between the Value added (current Local Currency Unit) in Bahamas and Value added (current Local Currency Unit) in Turkmenistan?
Make the answer very short. -1.51e+09. In the year 2001, what is the difference between the Value added (current Local Currency Unit) of Sri Lanka and Value added (current Local Currency Unit) of Turkmenistan?
Keep it short and to the point. 2.48e+11. In the year 2002, what is the difference between the Value added (current Local Currency Unit) in Bahamas and Value added (current Local Currency Unit) in Sri Lanka?
Ensure brevity in your answer.  -2.33e+11. In the year 2002, what is the difference between the Value added (current Local Currency Unit) in Bahamas and Value added (current Local Currency Unit) in Turkmenistan?
Give a very brief answer. -1.69e+09. In the year 2002, what is the difference between the Value added (current Local Currency Unit) of Sri Lanka and Value added (current Local Currency Unit) of Turkmenistan?
Ensure brevity in your answer.  2.32e+11. What is the ratio of the Value added (current Local Currency Unit) in Bahamas in 1995 to that in 1996?
Your answer should be compact. 1.02. What is the ratio of the Value added (current Local Currency Unit) of Sri Lanka in 1995 to that in 1996?
Offer a very short reply. 0.88. What is the ratio of the Value added (current Local Currency Unit) of Turkmenistan in 1995 to that in 1996?
Make the answer very short. 0.11. What is the ratio of the Value added (current Local Currency Unit) of Bahamas in 1995 to that in 1997?
Offer a terse response. 0.63. What is the ratio of the Value added (current Local Currency Unit) in Sri Lanka in 1995 to that in 1997?
Offer a terse response. 0.78. What is the ratio of the Value added (current Local Currency Unit) in Turkmenistan in 1995 to that in 1997?
Make the answer very short. 0.05. What is the ratio of the Value added (current Local Currency Unit) of Bahamas in 1995 to that in 1998?
Offer a terse response. 0.66. What is the ratio of the Value added (current Local Currency Unit) of Sri Lanka in 1995 to that in 1998?
Give a very brief answer. 0.71. What is the ratio of the Value added (current Local Currency Unit) in Turkmenistan in 1995 to that in 1998?
Provide a succinct answer. 0.03. What is the ratio of the Value added (current Local Currency Unit) of Bahamas in 1995 to that in 1999?
Your response must be concise. 0.66. What is the ratio of the Value added (current Local Currency Unit) in Sri Lanka in 1995 to that in 1999?
Offer a terse response. 0.67. What is the ratio of the Value added (current Local Currency Unit) of Turkmenistan in 1995 to that in 1999?
Keep it short and to the point. 0.02. What is the ratio of the Value added (current Local Currency Unit) in Bahamas in 1995 to that in 2000?
Keep it short and to the point. 0.59. What is the ratio of the Value added (current Local Currency Unit) in Sri Lanka in 1995 to that in 2000?
Ensure brevity in your answer.  0.61. What is the ratio of the Value added (current Local Currency Unit) in Turkmenistan in 1995 to that in 2000?
Your response must be concise. 0.02. What is the ratio of the Value added (current Local Currency Unit) in Bahamas in 1995 to that in 2001?
Your answer should be compact. 0.62. What is the ratio of the Value added (current Local Currency Unit) in Sri Lanka in 1995 to that in 2001?
Your answer should be compact. 0.55. What is the ratio of the Value added (current Local Currency Unit) in Turkmenistan in 1995 to that in 2001?
Ensure brevity in your answer.  0.01. What is the ratio of the Value added (current Local Currency Unit) of Bahamas in 1995 to that in 2002?
Provide a short and direct response. 0.48. What is the ratio of the Value added (current Local Currency Unit) of Sri Lanka in 1995 to that in 2002?
Provide a succinct answer. 0.59. What is the ratio of the Value added (current Local Currency Unit) in Turkmenistan in 1995 to that in 2002?
Provide a short and direct response. 0.01. What is the ratio of the Value added (current Local Currency Unit) in Bahamas in 1996 to that in 1997?
Provide a succinct answer. 0.62. What is the ratio of the Value added (current Local Currency Unit) of Sri Lanka in 1996 to that in 1997?
Ensure brevity in your answer.  0.89. What is the ratio of the Value added (current Local Currency Unit) of Turkmenistan in 1996 to that in 1997?
Offer a terse response. 0.44. What is the ratio of the Value added (current Local Currency Unit) in Bahamas in 1996 to that in 1998?
Make the answer very short. 0.65. What is the ratio of the Value added (current Local Currency Unit) in Sri Lanka in 1996 to that in 1998?
Provide a short and direct response. 0.81. What is the ratio of the Value added (current Local Currency Unit) in Turkmenistan in 1996 to that in 1998?
Your answer should be compact. 0.28. What is the ratio of the Value added (current Local Currency Unit) in Bahamas in 1996 to that in 1999?
Provide a short and direct response. 0.65. What is the ratio of the Value added (current Local Currency Unit) of Sri Lanka in 1996 to that in 1999?
Ensure brevity in your answer.  0.76. What is the ratio of the Value added (current Local Currency Unit) of Turkmenistan in 1996 to that in 1999?
Keep it short and to the point. 0.2. What is the ratio of the Value added (current Local Currency Unit) of Bahamas in 1996 to that in 2000?
Make the answer very short. 0.58. What is the ratio of the Value added (current Local Currency Unit) in Sri Lanka in 1996 to that in 2000?
Provide a short and direct response. 0.7. What is the ratio of the Value added (current Local Currency Unit) of Turkmenistan in 1996 to that in 2000?
Give a very brief answer. 0.17. What is the ratio of the Value added (current Local Currency Unit) of Bahamas in 1996 to that in 2001?
Your answer should be compact. 0.61. What is the ratio of the Value added (current Local Currency Unit) of Turkmenistan in 1996 to that in 2001?
Ensure brevity in your answer.  0.12. What is the ratio of the Value added (current Local Currency Unit) in Bahamas in 1996 to that in 2002?
Ensure brevity in your answer.  0.47. What is the ratio of the Value added (current Local Currency Unit) of Sri Lanka in 1996 to that in 2002?
Give a very brief answer. 0.67. What is the ratio of the Value added (current Local Currency Unit) in Turkmenistan in 1996 to that in 2002?
Your response must be concise. 0.1. What is the ratio of the Value added (current Local Currency Unit) of Bahamas in 1997 to that in 1998?
Offer a terse response. 1.05. What is the ratio of the Value added (current Local Currency Unit) of Sri Lanka in 1997 to that in 1998?
Give a very brief answer. 0.91. What is the ratio of the Value added (current Local Currency Unit) of Turkmenistan in 1997 to that in 1998?
Make the answer very short. 0.64. What is the ratio of the Value added (current Local Currency Unit) in Bahamas in 1997 to that in 1999?
Your answer should be very brief. 1.04. What is the ratio of the Value added (current Local Currency Unit) in Sri Lanka in 1997 to that in 1999?
Keep it short and to the point. 0.85. What is the ratio of the Value added (current Local Currency Unit) in Turkmenistan in 1997 to that in 1999?
Your answer should be very brief. 0.45. What is the ratio of the Value added (current Local Currency Unit) in Bahamas in 1997 to that in 2000?
Provide a short and direct response. 0.93. What is the ratio of the Value added (current Local Currency Unit) in Sri Lanka in 1997 to that in 2000?
Make the answer very short. 0.79. What is the ratio of the Value added (current Local Currency Unit) in Turkmenistan in 1997 to that in 2000?
Ensure brevity in your answer.  0.38. What is the ratio of the Value added (current Local Currency Unit) in Bahamas in 1997 to that in 2001?
Keep it short and to the point. 0.98. What is the ratio of the Value added (current Local Currency Unit) in Sri Lanka in 1997 to that in 2001?
Your answer should be compact. 0.7. What is the ratio of the Value added (current Local Currency Unit) in Turkmenistan in 1997 to that in 2001?
Give a very brief answer. 0.27. What is the ratio of the Value added (current Local Currency Unit) of Bahamas in 1997 to that in 2002?
Make the answer very short. 0.76. What is the ratio of the Value added (current Local Currency Unit) in Sri Lanka in 1997 to that in 2002?
Your response must be concise. 0.75. What is the ratio of the Value added (current Local Currency Unit) in Turkmenistan in 1997 to that in 2002?
Your answer should be very brief. 0.24. What is the ratio of the Value added (current Local Currency Unit) of Sri Lanka in 1998 to that in 1999?
Your response must be concise. 0.94. What is the ratio of the Value added (current Local Currency Unit) of Turkmenistan in 1998 to that in 1999?
Your response must be concise. 0.71. What is the ratio of the Value added (current Local Currency Unit) in Bahamas in 1998 to that in 2000?
Your answer should be compact. 0.89. What is the ratio of the Value added (current Local Currency Unit) of Sri Lanka in 1998 to that in 2000?
Ensure brevity in your answer.  0.86. What is the ratio of the Value added (current Local Currency Unit) in Turkmenistan in 1998 to that in 2000?
Offer a terse response. 0.6. What is the ratio of the Value added (current Local Currency Unit) of Bahamas in 1998 to that in 2001?
Provide a succinct answer. 0.94. What is the ratio of the Value added (current Local Currency Unit) in Sri Lanka in 1998 to that in 2001?
Provide a short and direct response. 0.77. What is the ratio of the Value added (current Local Currency Unit) of Turkmenistan in 1998 to that in 2001?
Your answer should be very brief. 0.42. What is the ratio of the Value added (current Local Currency Unit) in Bahamas in 1998 to that in 2002?
Give a very brief answer. 0.73. What is the ratio of the Value added (current Local Currency Unit) in Sri Lanka in 1998 to that in 2002?
Provide a short and direct response. 0.82. What is the ratio of the Value added (current Local Currency Unit) in Turkmenistan in 1998 to that in 2002?
Your answer should be compact. 0.37. What is the ratio of the Value added (current Local Currency Unit) in Bahamas in 1999 to that in 2000?
Give a very brief answer. 0.89. What is the ratio of the Value added (current Local Currency Unit) of Sri Lanka in 1999 to that in 2000?
Your answer should be very brief. 0.92. What is the ratio of the Value added (current Local Currency Unit) in Turkmenistan in 1999 to that in 2000?
Give a very brief answer. 0.85. What is the ratio of the Value added (current Local Currency Unit) of Bahamas in 1999 to that in 2001?
Provide a short and direct response. 0.94. What is the ratio of the Value added (current Local Currency Unit) in Sri Lanka in 1999 to that in 2001?
Your response must be concise. 0.82. What is the ratio of the Value added (current Local Currency Unit) of Turkmenistan in 1999 to that in 2001?
Offer a very short reply. 0.6. What is the ratio of the Value added (current Local Currency Unit) in Bahamas in 1999 to that in 2002?
Your answer should be very brief. 0.73. What is the ratio of the Value added (current Local Currency Unit) of Sri Lanka in 1999 to that in 2002?
Keep it short and to the point. 0.88. What is the ratio of the Value added (current Local Currency Unit) of Turkmenistan in 1999 to that in 2002?
Your response must be concise. 0.53. What is the ratio of the Value added (current Local Currency Unit) of Bahamas in 2000 to that in 2001?
Make the answer very short. 1.05. What is the ratio of the Value added (current Local Currency Unit) of Sri Lanka in 2000 to that in 2001?
Give a very brief answer. 0.9. What is the ratio of the Value added (current Local Currency Unit) of Turkmenistan in 2000 to that in 2001?
Your answer should be compact. 0.71. What is the ratio of the Value added (current Local Currency Unit) of Bahamas in 2000 to that in 2002?
Ensure brevity in your answer.  0.82. What is the ratio of the Value added (current Local Currency Unit) in Sri Lanka in 2000 to that in 2002?
Make the answer very short. 0.96. What is the ratio of the Value added (current Local Currency Unit) of Turkmenistan in 2000 to that in 2002?
Ensure brevity in your answer.  0.62. What is the ratio of the Value added (current Local Currency Unit) of Bahamas in 2001 to that in 2002?
Your response must be concise. 0.78. What is the ratio of the Value added (current Local Currency Unit) in Sri Lanka in 2001 to that in 2002?
Offer a terse response. 1.07. What is the ratio of the Value added (current Local Currency Unit) of Turkmenistan in 2001 to that in 2002?
Give a very brief answer. 0.88. What is the difference between the highest and the second highest Value added (current Local Currency Unit) of Bahamas?
Your answer should be compact. 3.62e+07. What is the difference between the highest and the second highest Value added (current Local Currency Unit) in Sri Lanka?
Offer a very short reply. 1.62e+1. What is the difference between the highest and the second highest Value added (current Local Currency Unit) in Turkmenistan?
Your answer should be very brief. 2.28e+08. What is the difference between the highest and the lowest Value added (current Local Currency Unit) of Bahamas?
Offer a terse response. 1.06e+08. What is the difference between the highest and the lowest Value added (current Local Currency Unit) in Sri Lanka?
Provide a succinct answer. 1.12e+11. What is the difference between the highest and the lowest Value added (current Local Currency Unit) in Turkmenistan?
Make the answer very short. 1.87e+09. 